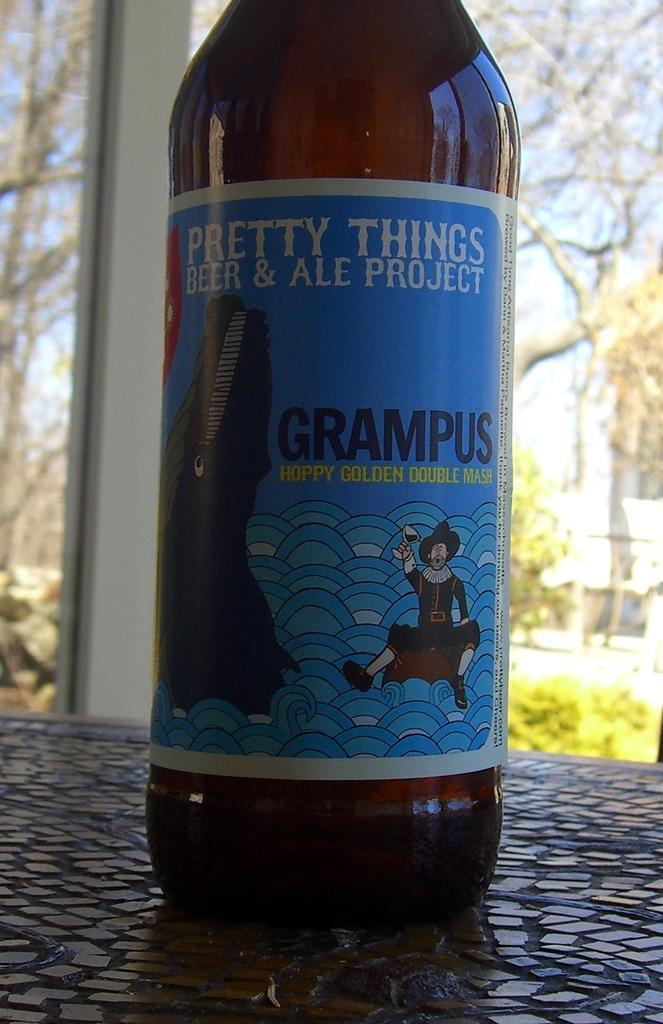Provide a one-sentence caption for the provided image. The bottle of Grampus is described as a hoppy golden double mash. 